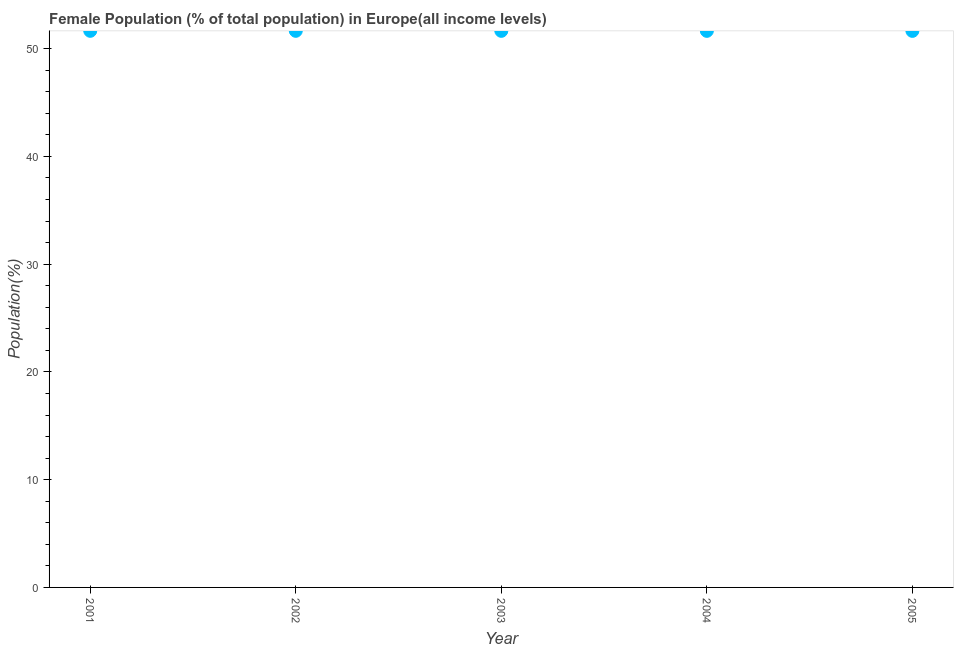What is the female population in 2001?
Your answer should be compact. 51.65. Across all years, what is the maximum female population?
Offer a very short reply. 51.65. Across all years, what is the minimum female population?
Keep it short and to the point. 51.65. What is the sum of the female population?
Provide a succinct answer. 258.26. What is the difference between the female population in 2001 and 2003?
Your answer should be compact. 0. What is the average female population per year?
Offer a very short reply. 51.65. What is the median female population?
Provide a succinct answer. 51.65. In how many years, is the female population greater than 18 %?
Keep it short and to the point. 5. Do a majority of the years between 2005 and 2002 (inclusive) have female population greater than 32 %?
Provide a succinct answer. Yes. What is the ratio of the female population in 2001 to that in 2003?
Keep it short and to the point. 1. Is the female population in 2002 less than that in 2004?
Provide a short and direct response. No. What is the difference between the highest and the second highest female population?
Ensure brevity in your answer.  0. What is the difference between the highest and the lowest female population?
Provide a succinct answer. 0. In how many years, is the female population greater than the average female population taken over all years?
Give a very brief answer. 2. Does the female population monotonically increase over the years?
Provide a succinct answer. No. How many years are there in the graph?
Your answer should be compact. 5. What is the difference between two consecutive major ticks on the Y-axis?
Offer a terse response. 10. Does the graph contain any zero values?
Provide a succinct answer. No. What is the title of the graph?
Provide a short and direct response. Female Population (% of total population) in Europe(all income levels). What is the label or title of the X-axis?
Ensure brevity in your answer.  Year. What is the label or title of the Y-axis?
Ensure brevity in your answer.  Population(%). What is the Population(%) in 2001?
Keep it short and to the point. 51.65. What is the Population(%) in 2002?
Your answer should be very brief. 51.65. What is the Population(%) in 2003?
Make the answer very short. 51.65. What is the Population(%) in 2004?
Your answer should be compact. 51.65. What is the Population(%) in 2005?
Keep it short and to the point. 51.65. What is the difference between the Population(%) in 2001 and 2002?
Provide a short and direct response. 0. What is the difference between the Population(%) in 2001 and 2003?
Make the answer very short. 0. What is the difference between the Population(%) in 2001 and 2004?
Give a very brief answer. 0. What is the difference between the Population(%) in 2001 and 2005?
Give a very brief answer. 0. What is the difference between the Population(%) in 2002 and 2003?
Keep it short and to the point. 0. What is the difference between the Population(%) in 2002 and 2004?
Keep it short and to the point. 0. What is the difference between the Population(%) in 2002 and 2005?
Offer a terse response. 0. What is the difference between the Population(%) in 2003 and 2004?
Keep it short and to the point. 0. What is the difference between the Population(%) in 2003 and 2005?
Offer a terse response. 0. What is the difference between the Population(%) in 2004 and 2005?
Your answer should be compact. 0. What is the ratio of the Population(%) in 2001 to that in 2002?
Offer a terse response. 1. What is the ratio of the Population(%) in 2001 to that in 2003?
Provide a short and direct response. 1. What is the ratio of the Population(%) in 2001 to that in 2005?
Keep it short and to the point. 1. What is the ratio of the Population(%) in 2002 to that in 2004?
Your response must be concise. 1. What is the ratio of the Population(%) in 2004 to that in 2005?
Give a very brief answer. 1. 